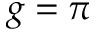<formula> <loc_0><loc_0><loc_500><loc_500>g = \pi</formula> 